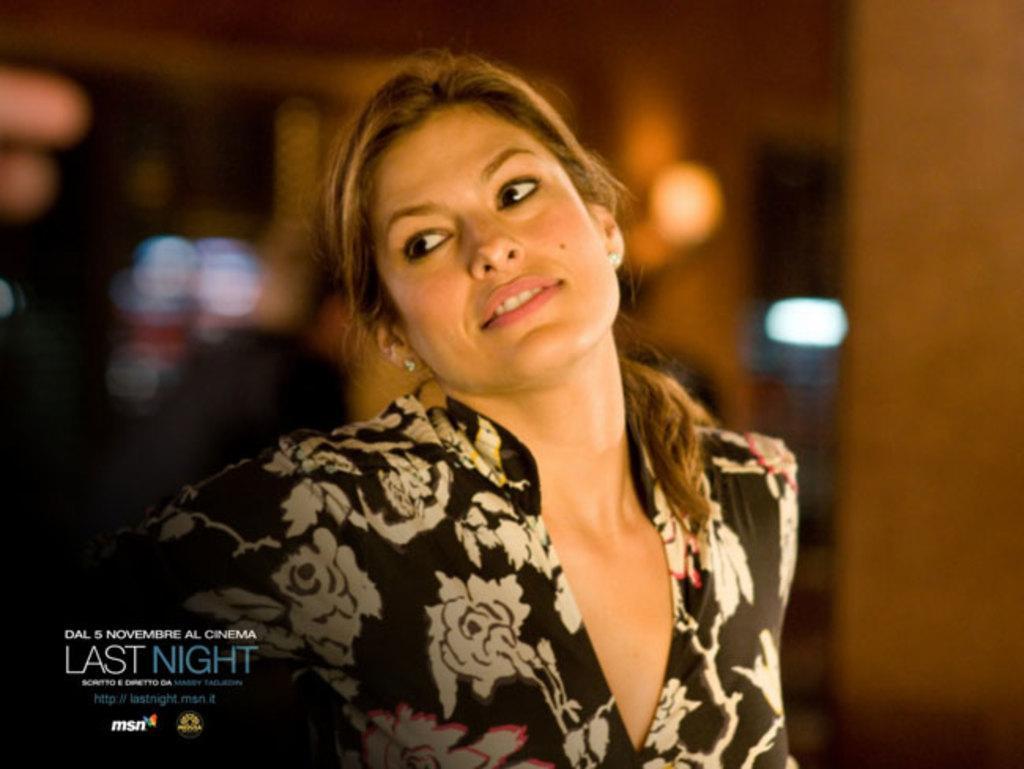How would you summarize this image in a sentence or two? Background portion of the picture is blurry and we can see the lights. In this picture we can see a woman. In the bottom left corner of the image we can see the information. 